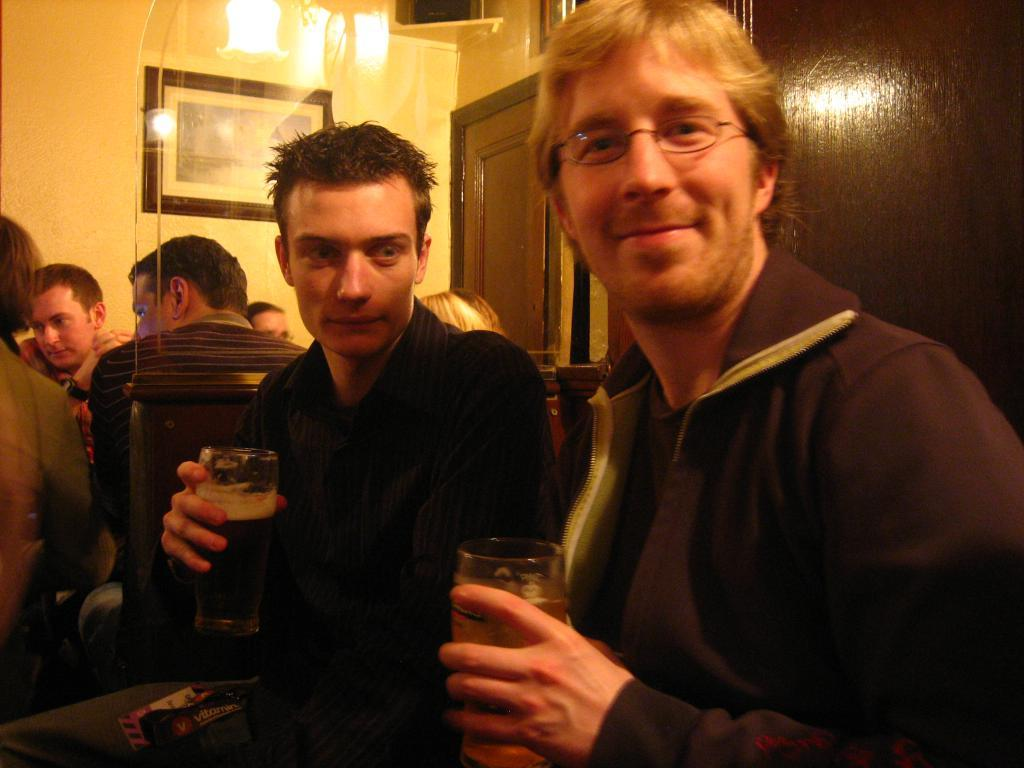What are the two persons in the image holding? The two persons in the image are holding a glass in their hands. What can be seen in the background of the image? There are other people sitting in the background, and there is a wall in the background. What is attached to the wall in the image? There is a photo frame attached to the wall. How many clovers can be seen growing on the wall in the image? There are no clovers visible in the image; the wall has a photo frame attached to it. 